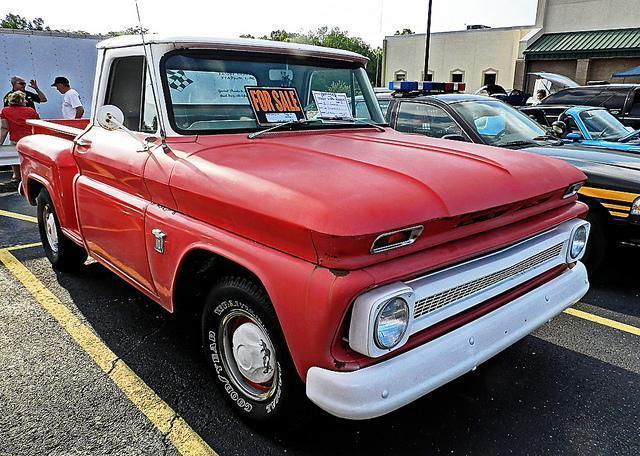How many boats are parked next to the red truck?
Give a very brief answer. 0. How many doors does the red truck have?
Give a very brief answer. 2. How many cars are there?
Give a very brief answer. 3. 